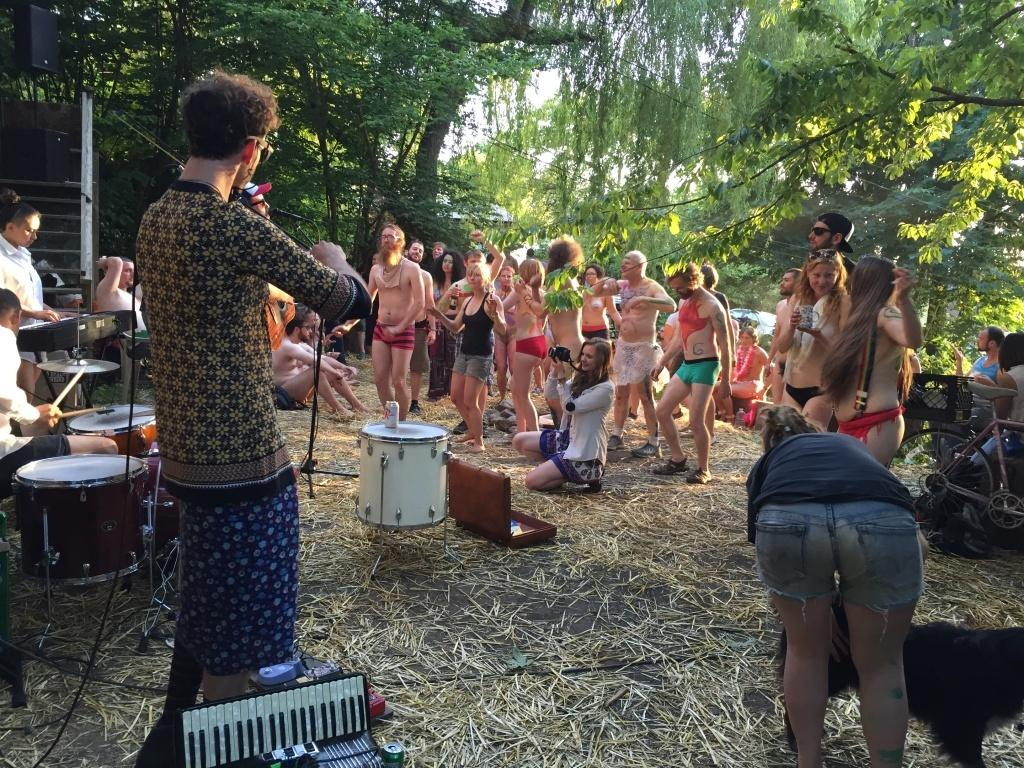What are the people in the image doing? The people in the image are playing musical instruments. Can you identify any specific musical instruments being played? Yes, drums are among the musical instruments being played. How many people are involved in the activity in the image? There is a group of people on the ground in the image. What type of natural environment is visible in the image? There are many trees and dry grass visible in the image. What type of lock is being used to secure the airplane in the image? There is no airplane present in the image; it features people playing musical instruments in a natural environment. Is there a writer in the image taking notes about the musical performance? There is no mention of a writer or any note-taking activity in the image. 